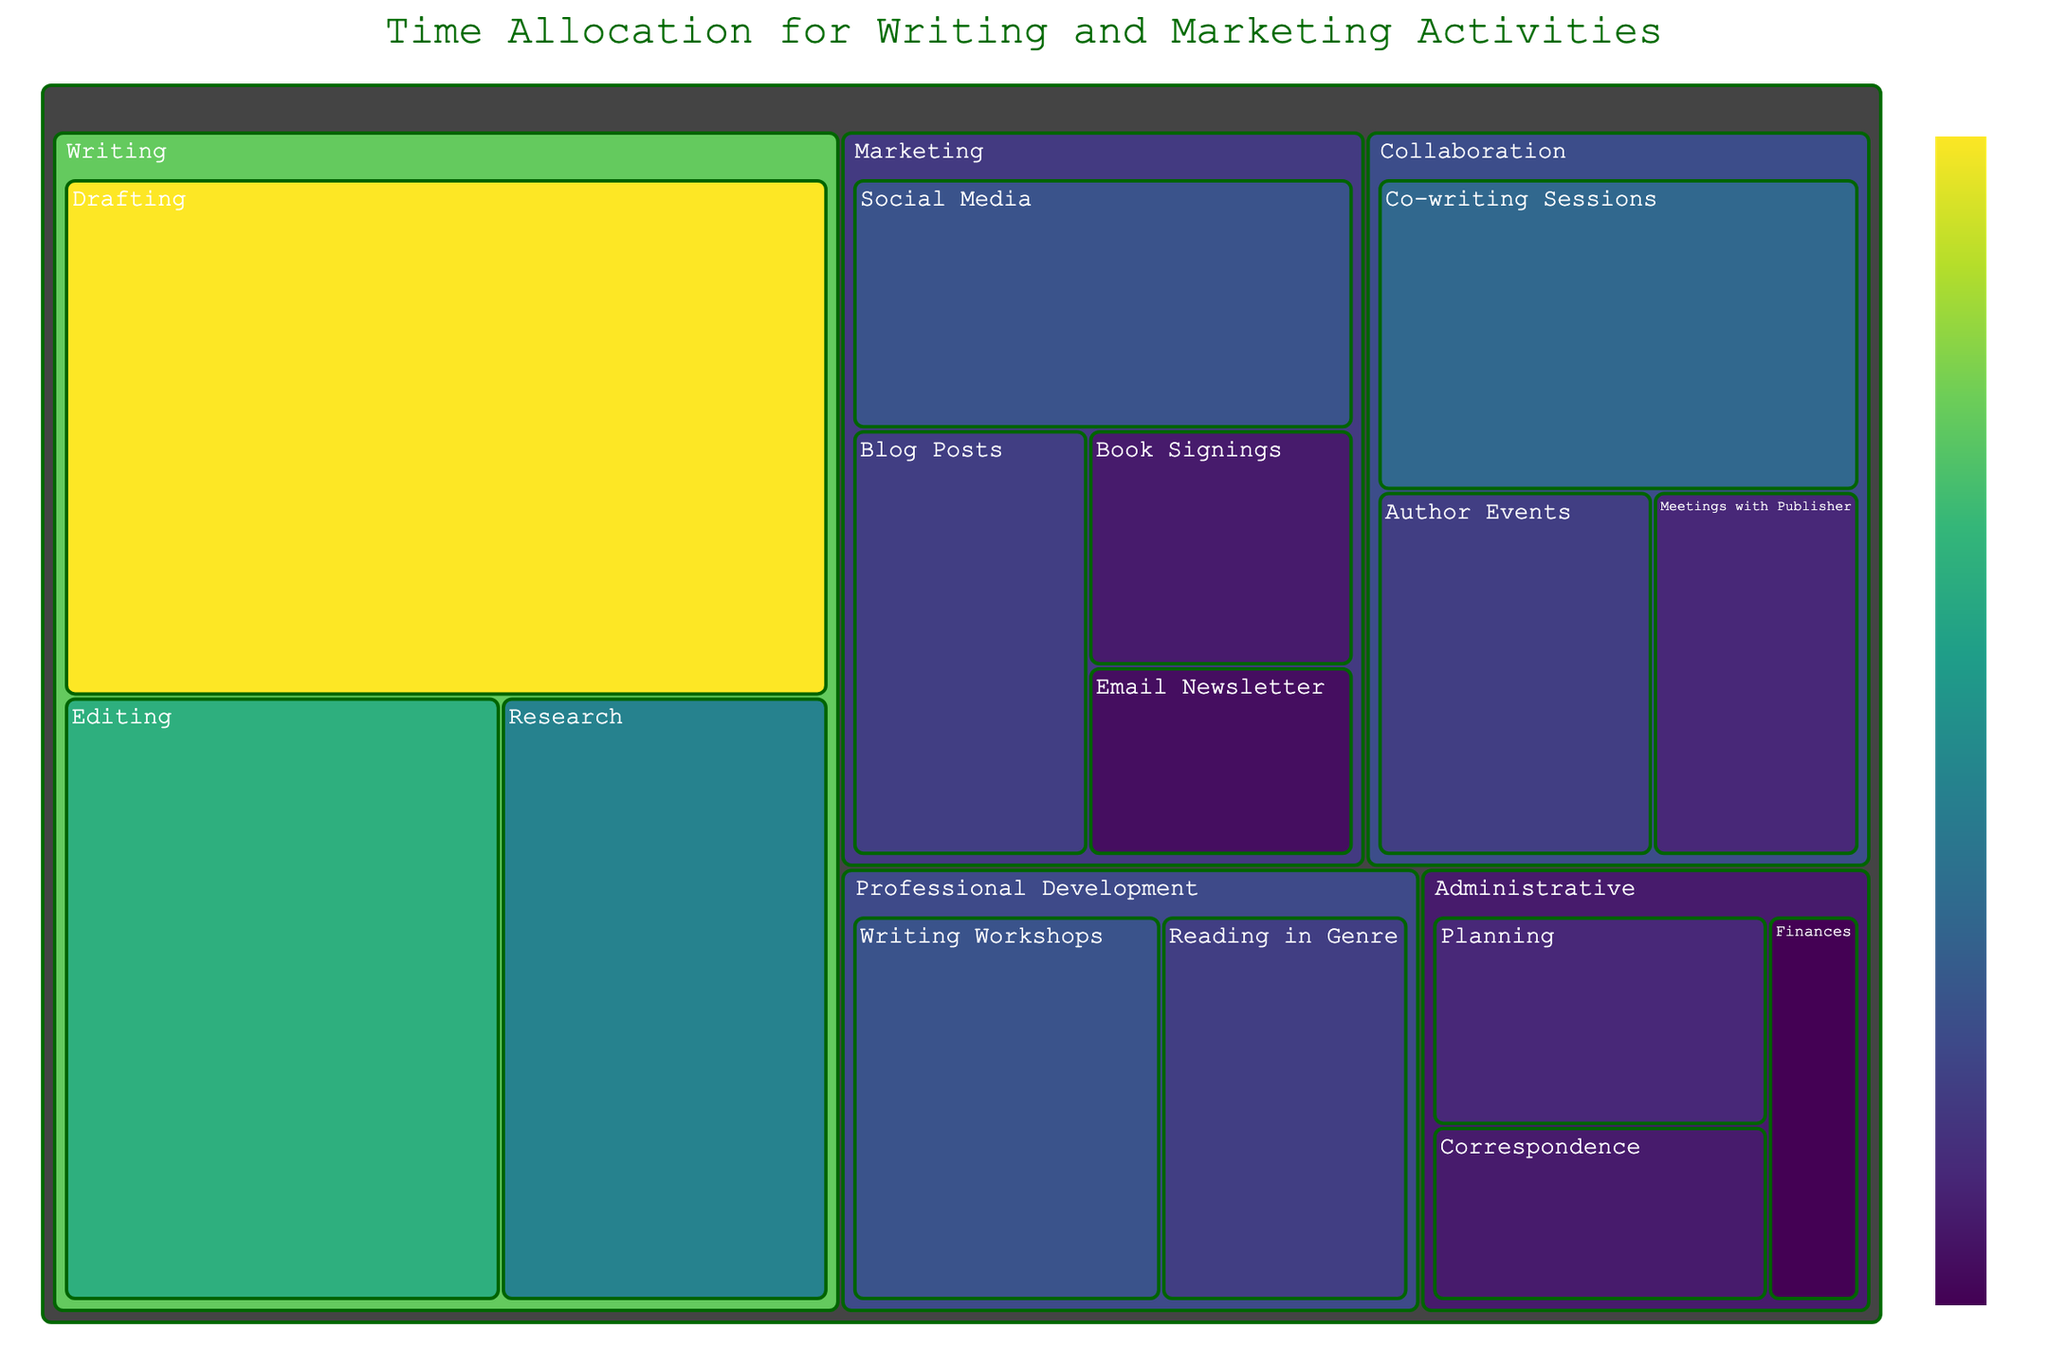Where does the author spend the most time? By looking at the largest segment in the figure, “Drafting” under the “Writing” category, which has the highest number of hours.
Answer: Drafting Which category takes up more time, Marketing or Professional Development? Sum the hours for each subcategory under Marketing (10 + 5 + 8 + 4 = 27) and under Professional Development (10 + 8 = 18). Marketing has more hours.
Answer: Marketing Between "Editing" and "Editing" activities, which consumes more hours? Compare the hours directly from the figure: Drafting (30) and Editing (20). Drafting consumes more hours.
Answer: Drafting How much time in total is allocated to Writing activities? Add the hours for all subcategories under Writing: 30 (Drafting) + 20 (Editing) + 15 (Research) = 65.
Answer: 65 Which collaboration activity takes the most time? Observe the figure and identify the subcategory under Collaboration with the highest hours: Co-writing Sessions (12).
Answer: Co-writing Sessions What is the total amount of hours spent on Administrative tasks? Sum the hours for all subcategories under Administrative: 5 (Correspondence) + 3 (Finances) + 6 (Planning) = 14.
Answer: 14 How many more hours are allocated to “Drafting” compared to “Social Media”? Deduct the hours of Social Media (10) from Drafting (30), which is 30 - 10 = 20.
Answer: 20 Which has a higher allocation of hours, “Meetings with Publisher” or “Author Events”? Look at the hours for each subcategory under Collaboration: Meetings with Publisher (6) and Author Events (8). Author Events have a higher allocation.
Answer: Author Events Is more time spent on “Research” or on the combined “Blog Posts” and “Book Signings”? First, sum the hours for Blog Posts (8) and Book Signings (5) which is 8 + 5 = 13, then compare Research (15) and 13.
Answer: Research What percentage of total time is spent on “Writing Workshops”? Find the total hours across all categories by summing up all subcategory hours: 30 + 20 + 15 + 10 + 5 + 8 + 4 + 6 + 8 + 12 + 10 + 8 + 5 + 3 + 6 = 155, then calculate the percentage for Writing Workshops: (10 / 155) * 100 ≈ 6.45%.
Answer: 6.45% 